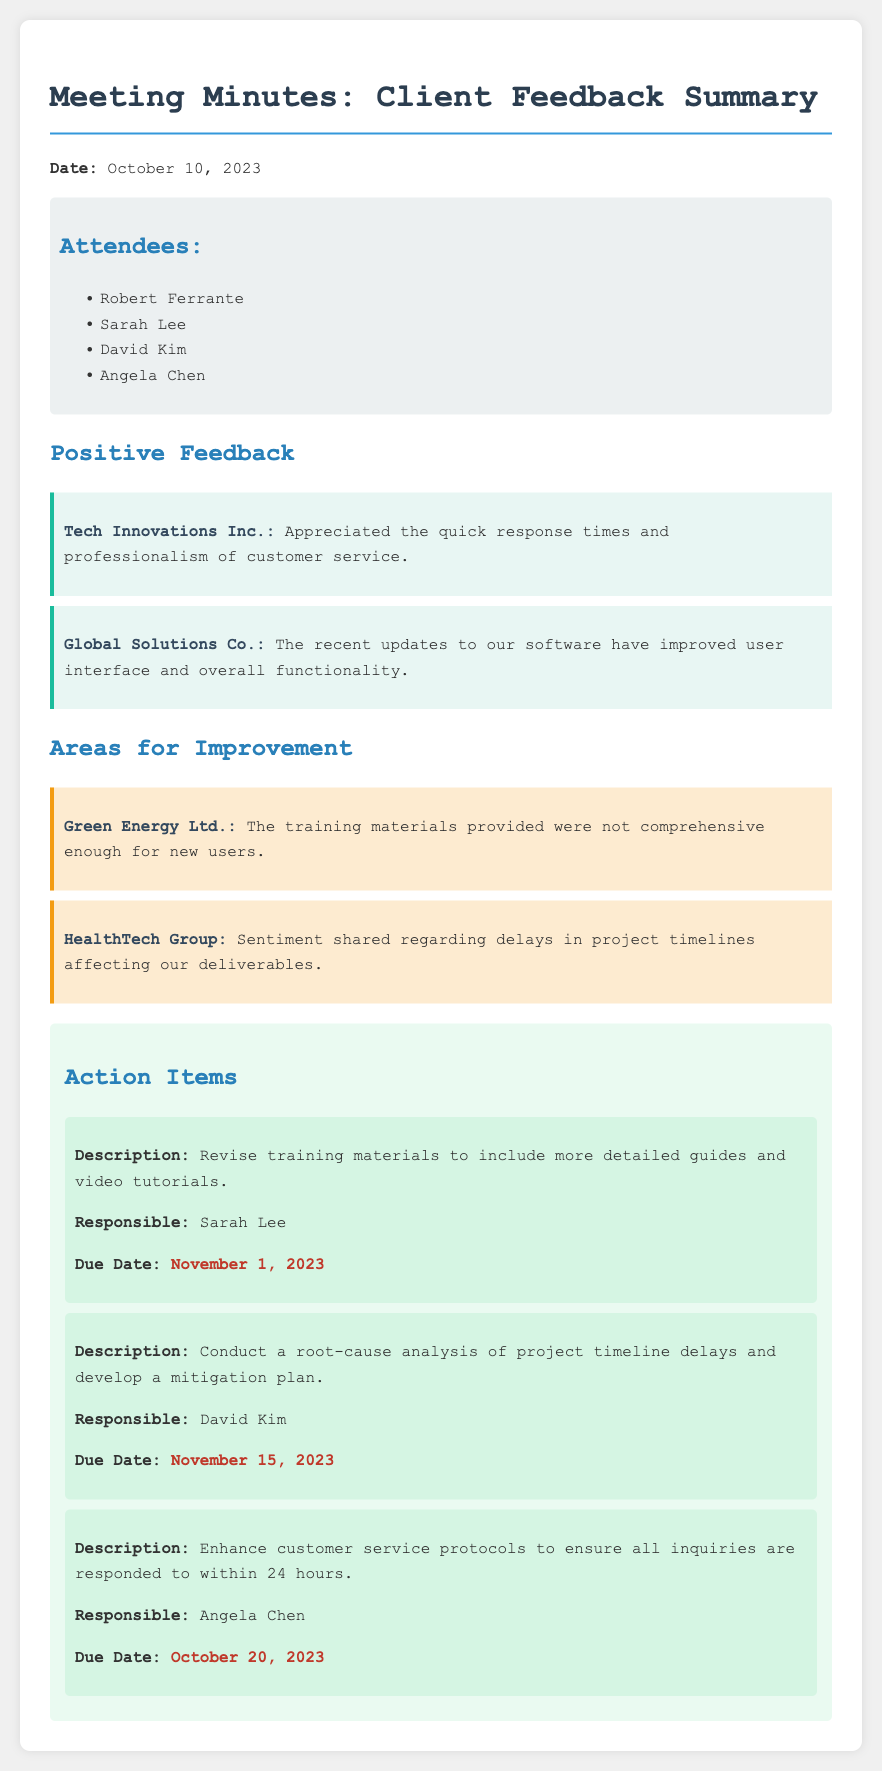what is the date of the meeting? The date of the meeting is specified at the beginning of the document, which is October 10, 2023.
Answer: October 10, 2023 who is responsible for revising training materials? The document lists action items including the person responsible for each, indicating that Sarah Lee is responsible for revising the training materials.
Answer: Sarah Lee what is the due date for enhancing customer service protocols? The document provides a due date for each action item, showing that the due date for enhancing customer service protocols is October 20, 2023.
Answer: October 20, 2023 which client appreciated quick response times? Positive feedback from clients includes specific companies, revealing that Tech Innovations Inc. appreciated quick response times.
Answer: Tech Innovations Inc what is described as an area for improvement regarding project timelines? The document mentions concerns from HealthTech Group about delays in project timelines affecting deliverables, indicating a specific area for improvement.
Answer: Delays in project timelines how many action items are listed in total? By counting the distinct action items provided in the document, there are three action items listed in total.
Answer: 3 who provided feedback about training materials? An area for improvement notes that Green Energy Ltd. had concerns regarding the training materials provided, highlighting the source of the feedback.
Answer: Green Energy Ltd what type of feedback did Global Solutions Co. provide? The document categorizes client feedback and specifies that Global Solutions Co. provided positive feedback regarding software updates.
Answer: Positive feedback 